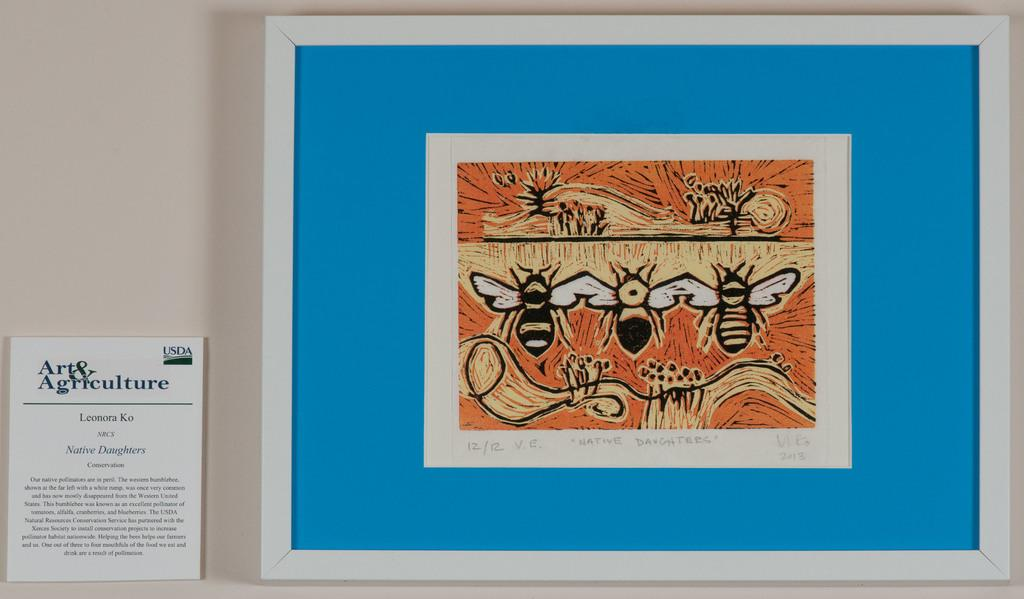What is hanging on the wall in the picture? There is a frame with an image and a board with text in the picture. How are the frame and the board attached to the wall? Both the frame and the board are attached to the wall. What type of lead can be seen in the picture? There is no lead present in the picture; it features a frame with an image and a board with text attached to the wall. 